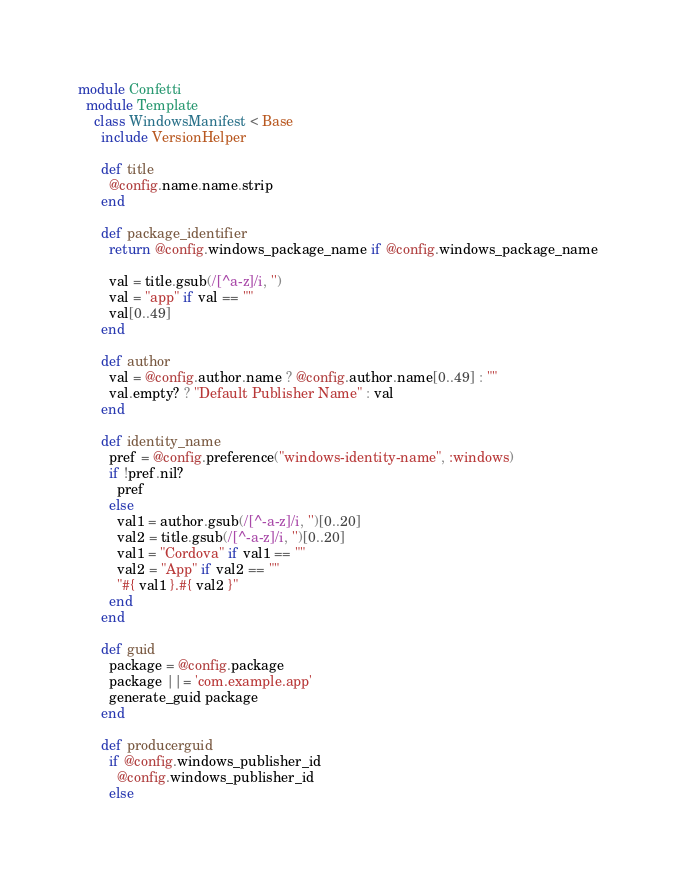<code> <loc_0><loc_0><loc_500><loc_500><_Ruby_>module Confetti
  module Template
    class WindowsManifest < Base
      include VersionHelper

      def title
        @config.name.name.strip
      end

      def package_identifier
        return @config.windows_package_name if @config.windows_package_name
        
        val = title.gsub(/[^a-z]/i, '')
        val = "app" if val == ""
        val[0..49]
      end

      def author
        val = @config.author.name ? @config.author.name[0..49] : ""
        val.empty? ? "Default Publisher Name" : val 
      end

      def identity_name
        pref = @config.preference("windows-identity-name", :windows)
        if !pref.nil?
          pref
        else
          val1 = author.gsub(/[^-a-z]/i, '')[0..20]
          val2 = title.gsub(/[^-a-z]/i, '')[0..20]
          val1 = "Cordova" if val1 == ""
          val2 = "App" if val2 == ""
          "#{ val1 }.#{ val2 }"
        end
      end

      def guid
        package = @config.package
        package ||= 'com.example.app'
        generate_guid package
      end
      
      def producerguid
        if @config.windows_publisher_id
          @config.windows_publisher_id
        else</code> 